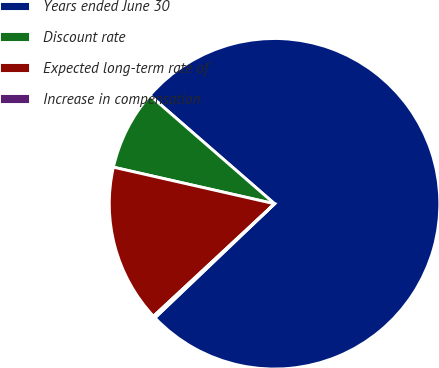Convert chart to OTSL. <chart><loc_0><loc_0><loc_500><loc_500><pie_chart><fcel>Years ended June 30<fcel>Discount rate<fcel>Expected long-term rate of<fcel>Increase in compensation<nl><fcel>76.49%<fcel>7.84%<fcel>15.47%<fcel>0.21%<nl></chart> 